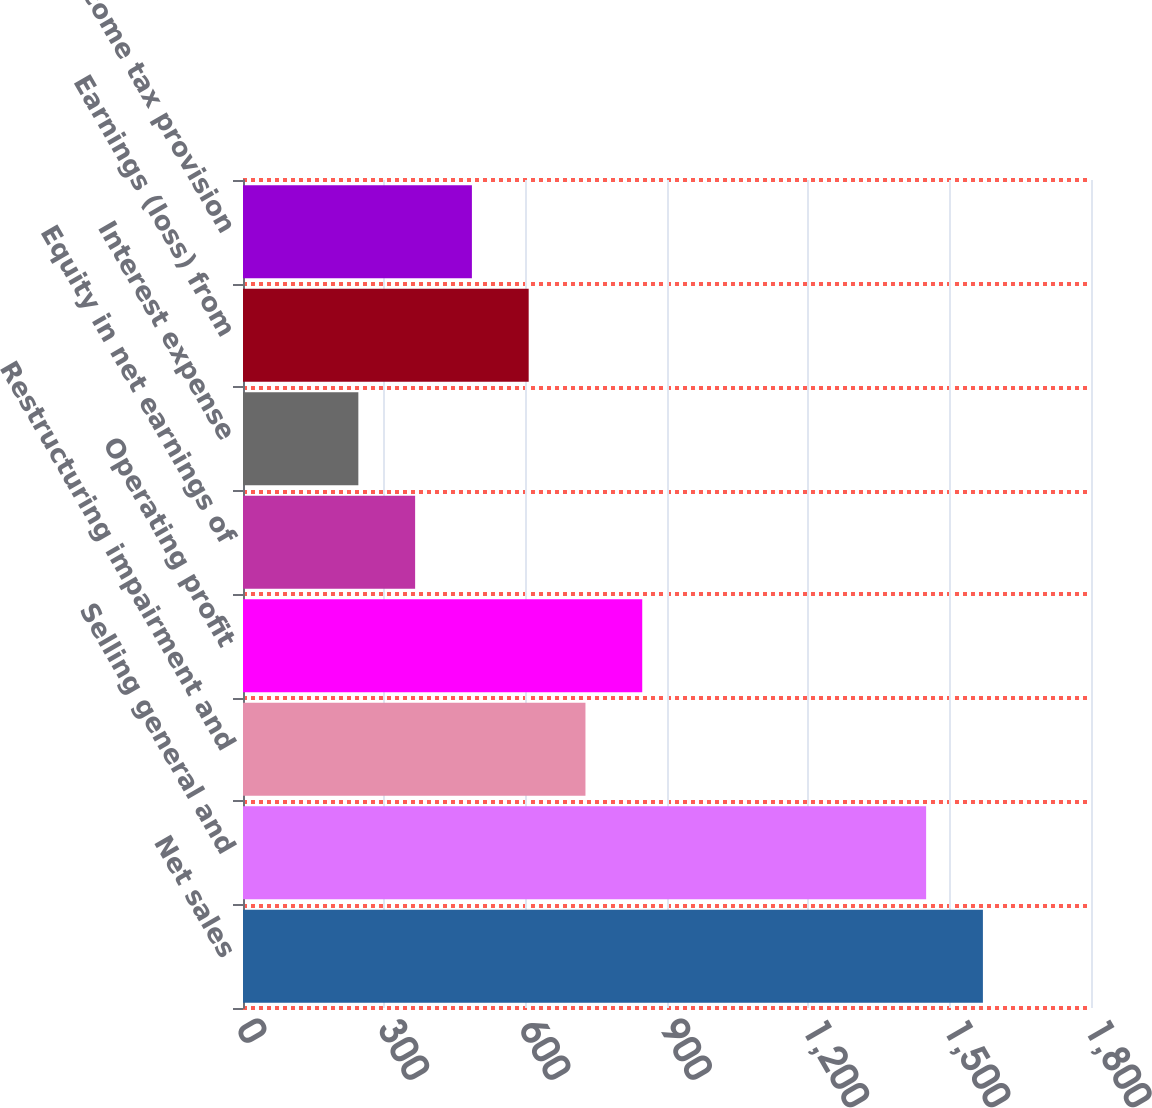<chart> <loc_0><loc_0><loc_500><loc_500><bar_chart><fcel>Net sales<fcel>Selling general and<fcel>Restructuring impairment and<fcel>Operating profit<fcel>Equity in net earnings of<fcel>Interest expense<fcel>Earnings (loss) from<fcel>Income tax provision<nl><fcel>1570.56<fcel>1450.04<fcel>726.92<fcel>847.44<fcel>365.36<fcel>244.84<fcel>606.4<fcel>485.88<nl></chart> 